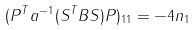Convert formula to latex. <formula><loc_0><loc_0><loc_500><loc_500>( P ^ { T } a ^ { - 1 } ( S ^ { T } B S ) P ) _ { 1 1 } = - 4 n _ { 1 }</formula> 